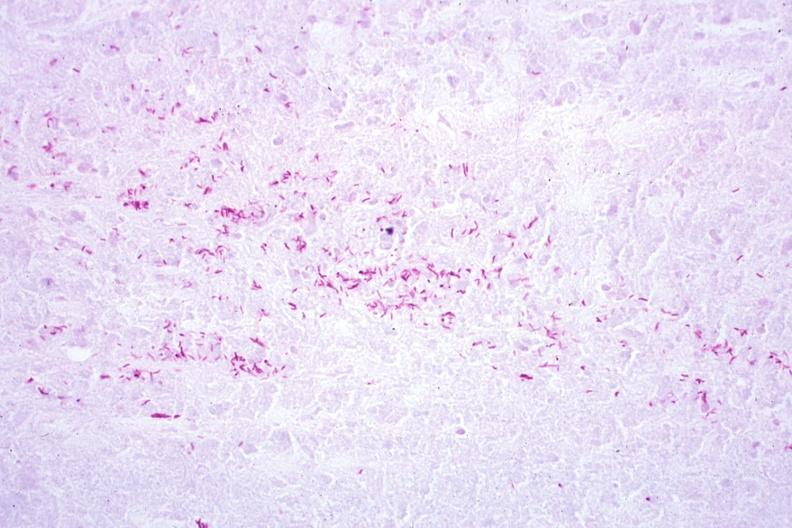s conjoined twins present?
Answer the question using a single word or phrase. No 